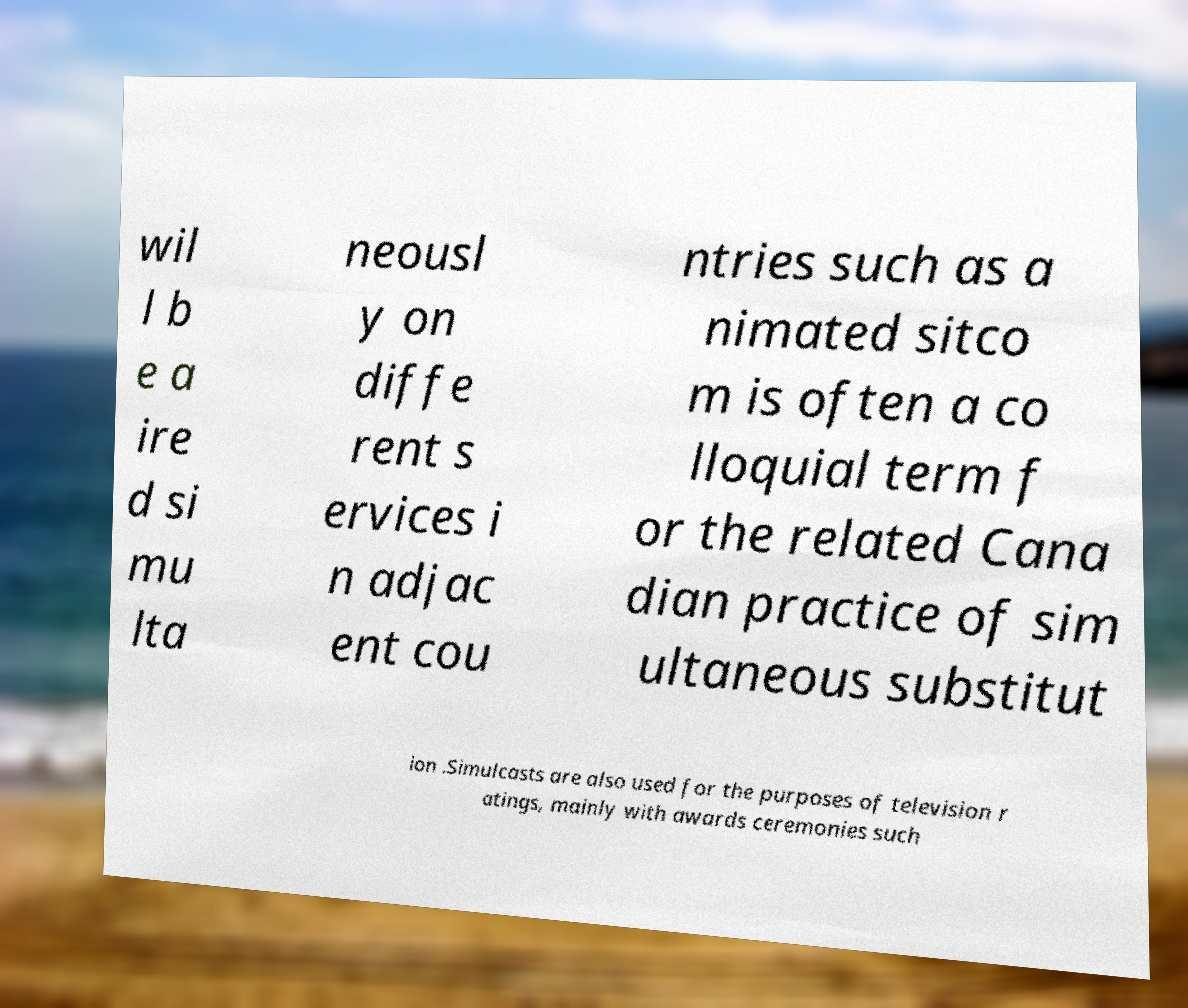There's text embedded in this image that I need extracted. Can you transcribe it verbatim? wil l b e a ire d si mu lta neousl y on diffe rent s ervices i n adjac ent cou ntries such as a nimated sitco m is often a co lloquial term f or the related Cana dian practice of sim ultaneous substitut ion .Simulcasts are also used for the purposes of television r atings, mainly with awards ceremonies such 